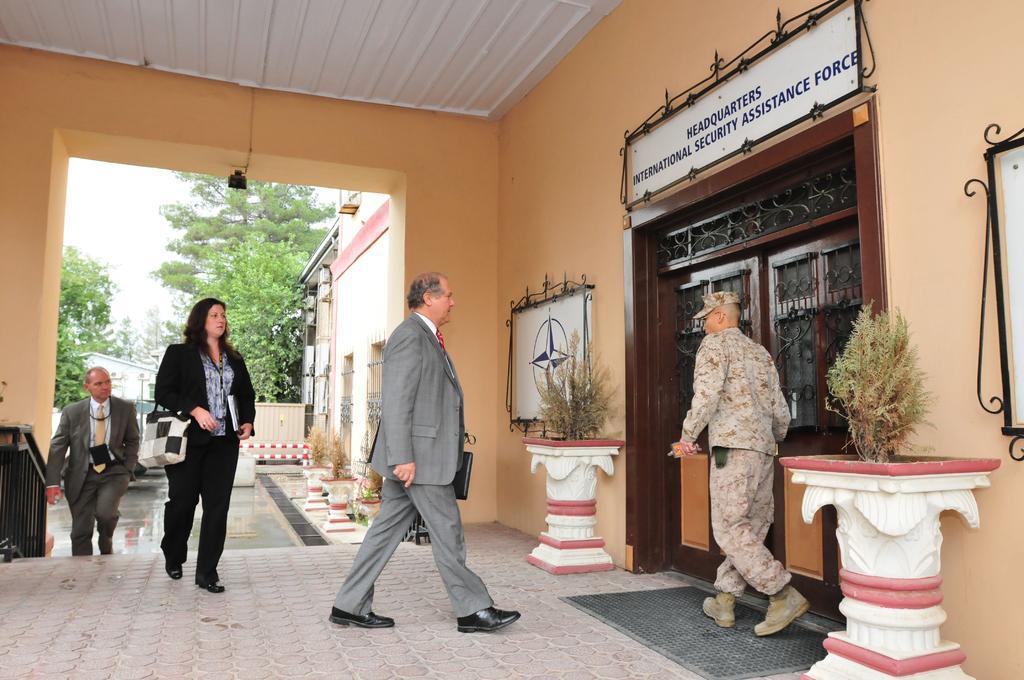Could you give a brief overview of what you see in this image? In this image we can see persons walking on the floor. On the right side of the image we can see house plants, boards, door, person and name board. In the background we can see building, trees and sky. 